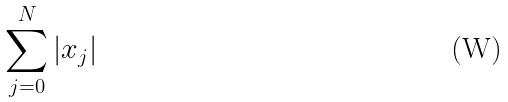<formula> <loc_0><loc_0><loc_500><loc_500>\sum _ { j = 0 } ^ { N } | x _ { j } |</formula> 